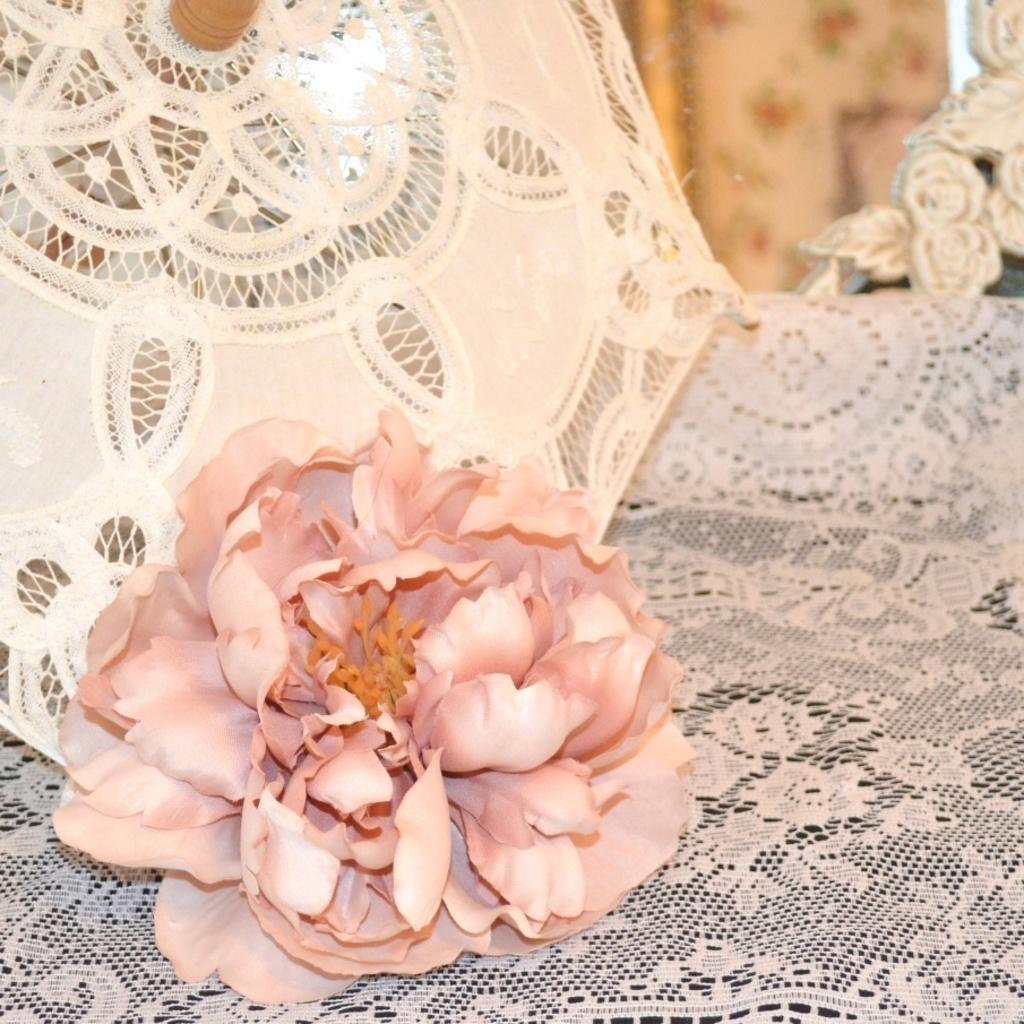What is the main subject of the image? There is a flower in the center of the image. What is the flower placed on? The flower is on a cloth. What can be seen in the background of the image? There is an umbrella in the background of the image. What type of fly is sitting on the selection of partners in the image? There is no fly or selection of partners present in the image; it features a flower on a cloth with an umbrella in the background. 